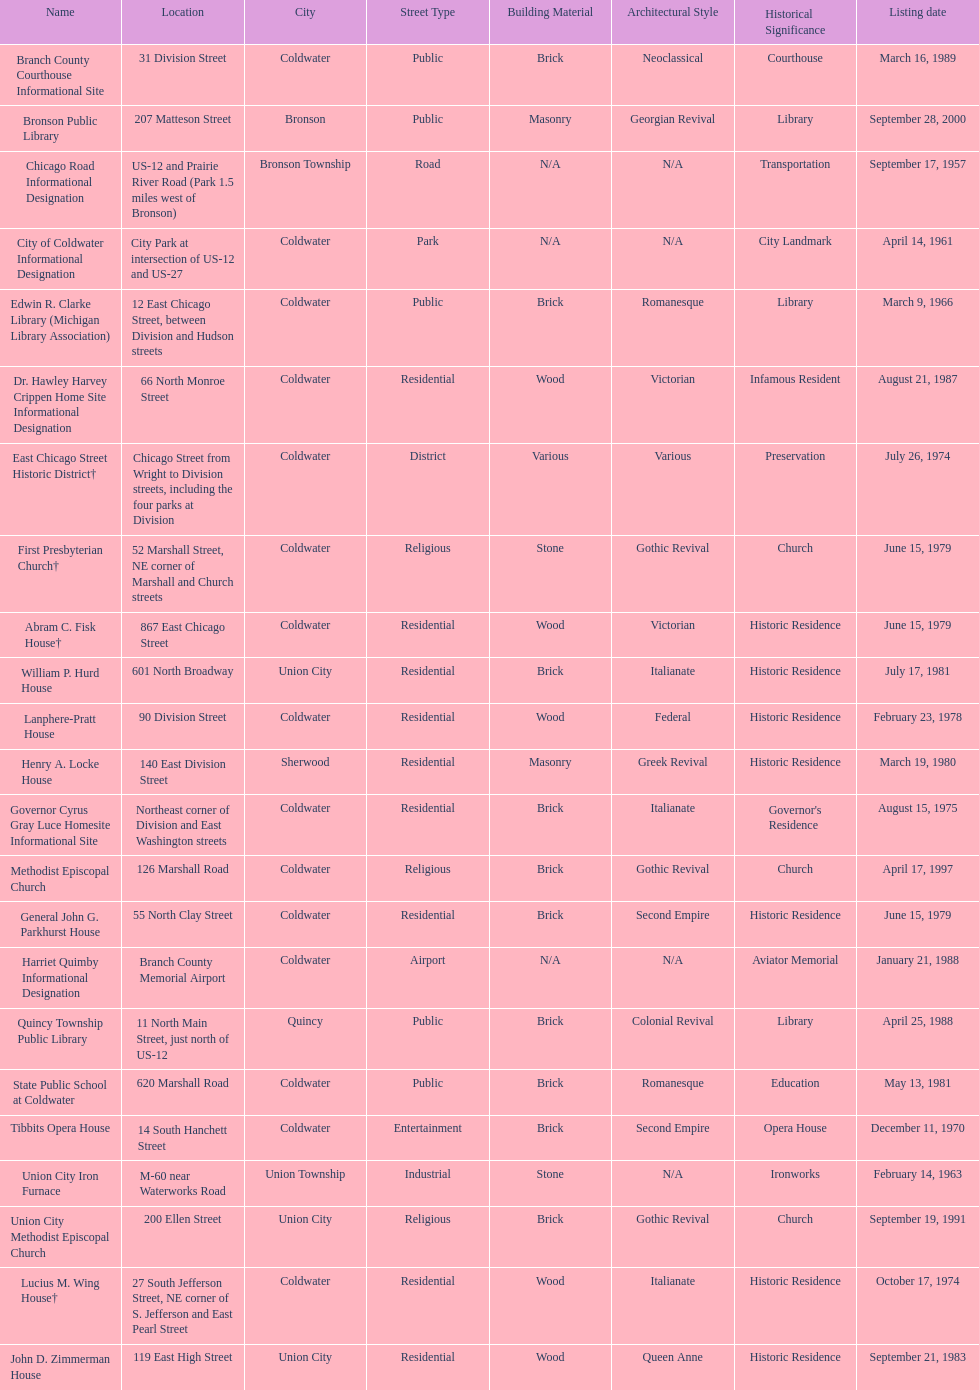How many sites were listed as historical before 1980? 12. 